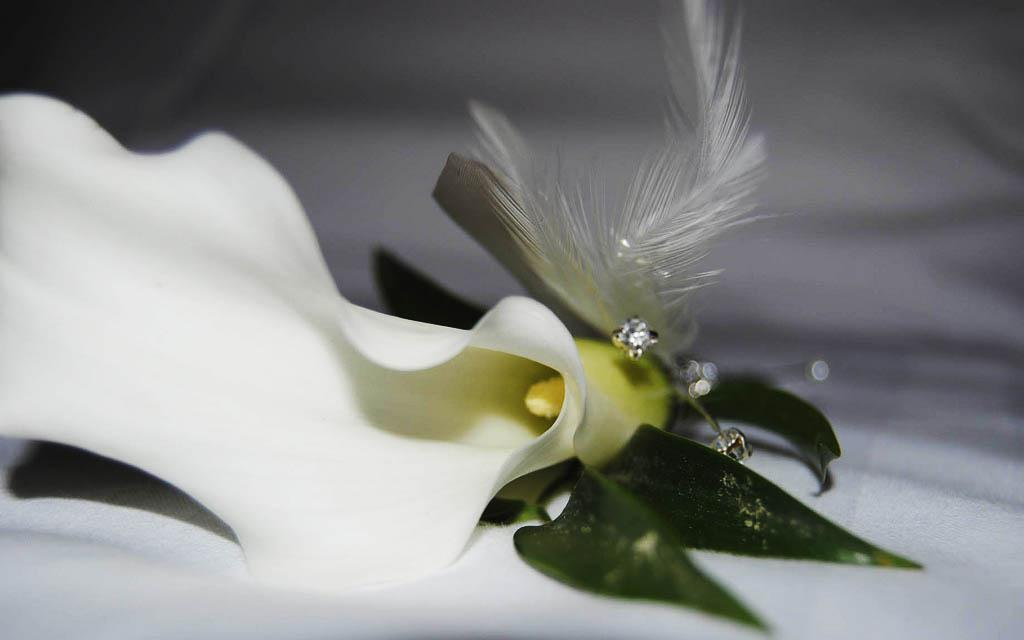What is the main subject of the image? The main subject of the image is a flower. Can you describe the flower's location in the image? The flower is on a surface in the image. How many veins can be seen in the flower in the image? There is no mention of veins in the image, as it features a flower on a surface. Can you tell me how many kittens are playing with the flower in the image? There are no kittens present in the image; it only features a flower on a surface. 